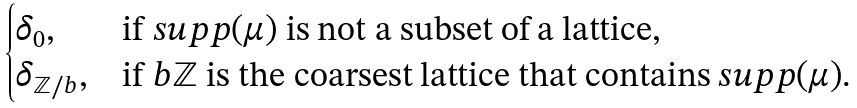<formula> <loc_0><loc_0><loc_500><loc_500>\begin{cases} \delta _ { 0 } , & \text {if\/ $supp    (\mu)$ is not a subset of a lattice} , \\ \delta _ { \mathbb { Z } / b } , & \text {if\/ $b\mathbb{Z}$ is the    coarsest lattice that contains $supp (\mu)$.} \end{cases}</formula> 